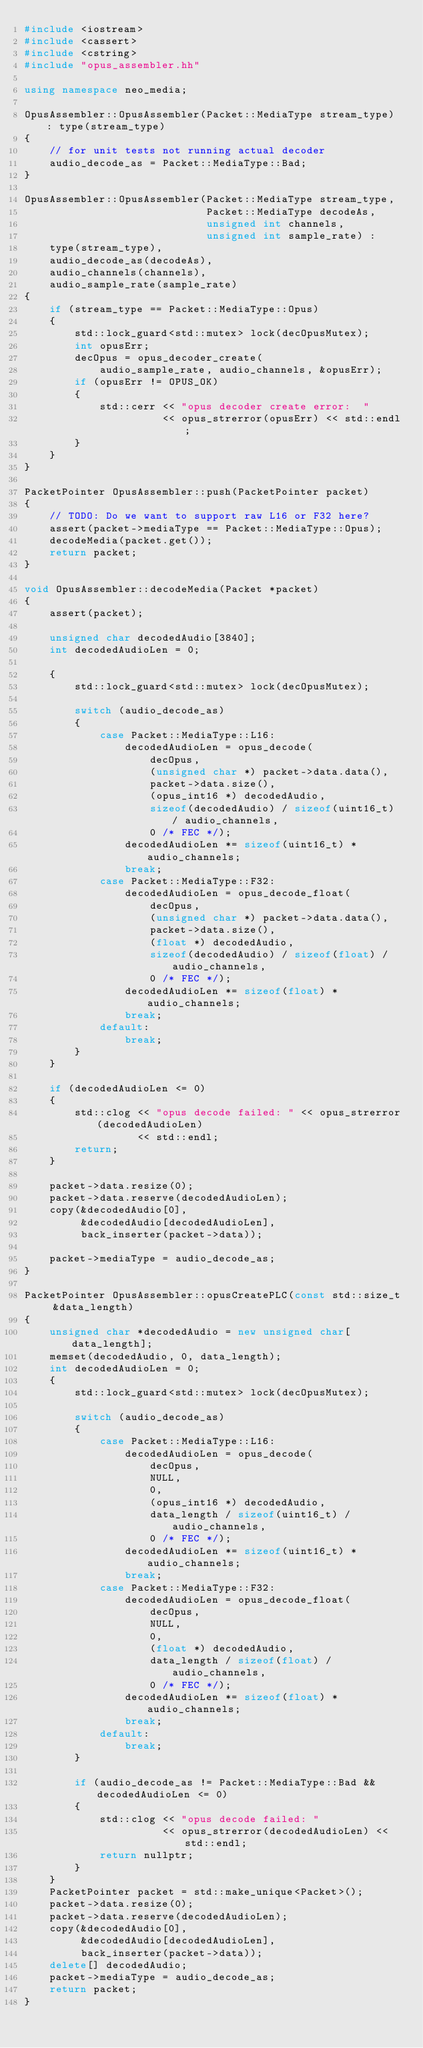Convert code to text. <code><loc_0><loc_0><loc_500><loc_500><_C++_>#include <iostream>
#include <cassert>
#include <cstring>
#include "opus_assembler.hh"

using namespace neo_media;

OpusAssembler::OpusAssembler(Packet::MediaType stream_type) : type(stream_type)
{
    // for unit tests not running actual decoder
    audio_decode_as = Packet::MediaType::Bad;
}

OpusAssembler::OpusAssembler(Packet::MediaType stream_type,
                             Packet::MediaType decodeAs,
                             unsigned int channels,
                             unsigned int sample_rate) :
    type(stream_type),
    audio_decode_as(decodeAs),
    audio_channels(channels),
    audio_sample_rate(sample_rate)
{
    if (stream_type == Packet::MediaType::Opus)
    {
        std::lock_guard<std::mutex> lock(decOpusMutex);
        int opusErr;
        decOpus = opus_decoder_create(
            audio_sample_rate, audio_channels, &opusErr);
        if (opusErr != OPUS_OK)
        {
            std::cerr << "opus decoder create error:  "
                      << opus_strerror(opusErr) << std::endl;
        }
    }
}

PacketPointer OpusAssembler::push(PacketPointer packet)
{
    // TODO: Do we want to support raw L16 or F32 here?
    assert(packet->mediaType == Packet::MediaType::Opus);
    decodeMedia(packet.get());
    return packet;
}

void OpusAssembler::decodeMedia(Packet *packet)
{
    assert(packet);

    unsigned char decodedAudio[3840];
    int decodedAudioLen = 0;

    {
        std::lock_guard<std::mutex> lock(decOpusMutex);

        switch (audio_decode_as)
        {
            case Packet::MediaType::L16:
                decodedAudioLen = opus_decode(
                    decOpus,
                    (unsigned char *) packet->data.data(),
                    packet->data.size(),
                    (opus_int16 *) decodedAudio,
                    sizeof(decodedAudio) / sizeof(uint16_t) / audio_channels,
                    0 /* FEC */);
                decodedAudioLen *= sizeof(uint16_t) * audio_channels;
                break;
            case Packet::MediaType::F32:
                decodedAudioLen = opus_decode_float(
                    decOpus,
                    (unsigned char *) packet->data.data(),
                    packet->data.size(),
                    (float *) decodedAudio,
                    sizeof(decodedAudio) / sizeof(float) / audio_channels,
                    0 /* FEC */);
                decodedAudioLen *= sizeof(float) * audio_channels;
                break;
            default:
                break;
        }
    }

    if (decodedAudioLen <= 0)
    {
        std::clog << "opus decode failed: " << opus_strerror(decodedAudioLen)
                  << std::endl;
        return;
    }

    packet->data.resize(0);
    packet->data.reserve(decodedAudioLen);
    copy(&decodedAudio[0],
         &decodedAudio[decodedAudioLen],
         back_inserter(packet->data));

    packet->mediaType = audio_decode_as;
}

PacketPointer OpusAssembler::opusCreatePLC(const std::size_t &data_length)
{
    unsigned char *decodedAudio = new unsigned char[data_length];
    memset(decodedAudio, 0, data_length);
    int decodedAudioLen = 0;
    {
        std::lock_guard<std::mutex> lock(decOpusMutex);

        switch (audio_decode_as)
        {
            case Packet::MediaType::L16:
                decodedAudioLen = opus_decode(
                    decOpus,
                    NULL,
                    0,
                    (opus_int16 *) decodedAudio,
                    data_length / sizeof(uint16_t) / audio_channels,
                    0 /* FEC */);
                decodedAudioLen *= sizeof(uint16_t) * audio_channels;
                break;
            case Packet::MediaType::F32:
                decodedAudioLen = opus_decode_float(
                    decOpus,
                    NULL,
                    0,
                    (float *) decodedAudio,
                    data_length / sizeof(float) / audio_channels,
                    0 /* FEC */);
                decodedAudioLen *= sizeof(float) * audio_channels;
                break;
            default:
                break;
        }

        if (audio_decode_as != Packet::MediaType::Bad && decodedAudioLen <= 0)
        {
            std::clog << "opus decode failed: "
                      << opus_strerror(decodedAudioLen) << std::endl;
            return nullptr;
        }
    }
    PacketPointer packet = std::make_unique<Packet>();
    packet->data.resize(0);
    packet->data.reserve(decodedAudioLen);
    copy(&decodedAudio[0],
         &decodedAudio[decodedAudioLen],
         back_inserter(packet->data));
    delete[] decodedAudio;
    packet->mediaType = audio_decode_as;
    return packet;
}
</code> 